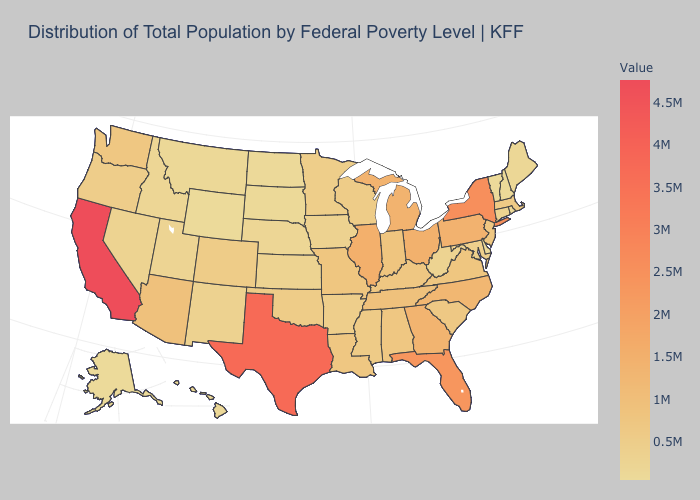Does California have the highest value in the USA?
Answer briefly. Yes. Is the legend a continuous bar?
Short answer required. Yes. Among the states that border Iowa , does Wisconsin have the highest value?
Be succinct. No. Which states have the lowest value in the USA?
Be succinct. Wyoming. Is the legend a continuous bar?
Concise answer only. Yes. 